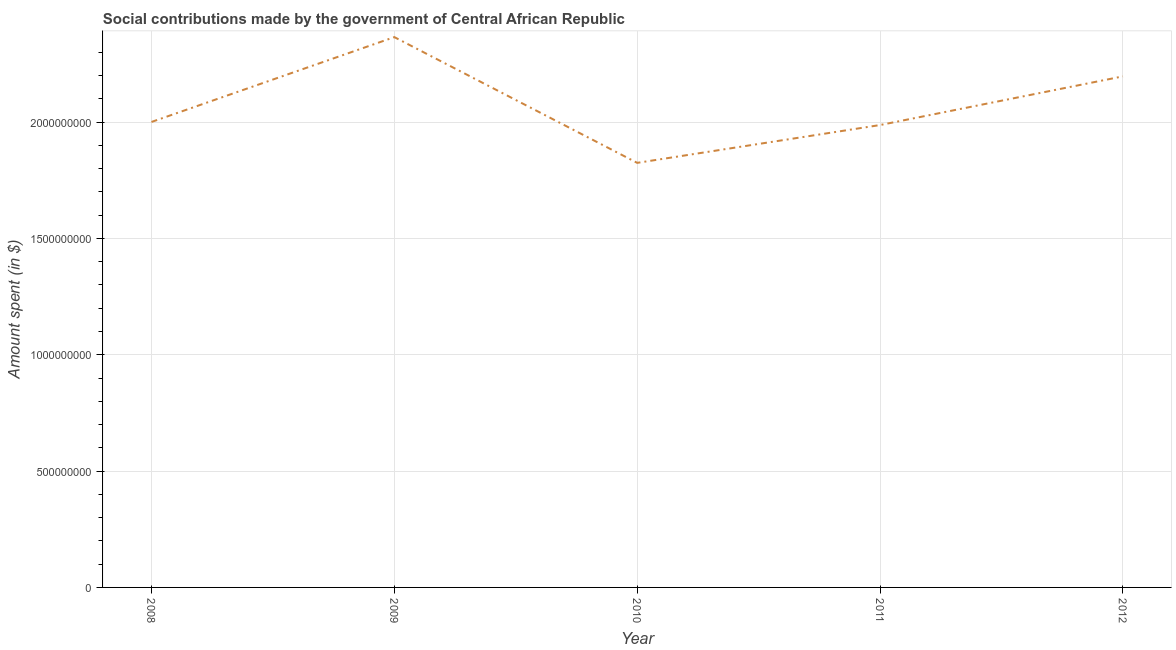What is the amount spent in making social contributions in 2010?
Make the answer very short. 1.82e+09. Across all years, what is the maximum amount spent in making social contributions?
Offer a terse response. 2.37e+09. Across all years, what is the minimum amount spent in making social contributions?
Provide a succinct answer. 1.82e+09. In which year was the amount spent in making social contributions maximum?
Give a very brief answer. 2009. In which year was the amount spent in making social contributions minimum?
Make the answer very short. 2010. What is the sum of the amount spent in making social contributions?
Offer a very short reply. 1.04e+1. What is the difference between the amount spent in making social contributions in 2010 and 2011?
Offer a very short reply. -1.63e+08. What is the average amount spent in making social contributions per year?
Give a very brief answer. 2.08e+09. What is the median amount spent in making social contributions?
Provide a short and direct response. 2.00e+09. What is the ratio of the amount spent in making social contributions in 2009 to that in 2011?
Provide a succinct answer. 1.19. What is the difference between the highest and the second highest amount spent in making social contributions?
Ensure brevity in your answer.  1.69e+08. What is the difference between the highest and the lowest amount spent in making social contributions?
Make the answer very short. 5.41e+08. In how many years, is the amount spent in making social contributions greater than the average amount spent in making social contributions taken over all years?
Offer a terse response. 2. Does the amount spent in making social contributions monotonically increase over the years?
Your answer should be very brief. No. How many lines are there?
Make the answer very short. 1. What is the difference between two consecutive major ticks on the Y-axis?
Offer a very short reply. 5.00e+08. Are the values on the major ticks of Y-axis written in scientific E-notation?
Offer a terse response. No. Does the graph contain any zero values?
Make the answer very short. No. What is the title of the graph?
Your answer should be very brief. Social contributions made by the government of Central African Republic. What is the label or title of the Y-axis?
Your response must be concise. Amount spent (in $). What is the Amount spent (in $) of 2008?
Your response must be concise. 2.00e+09. What is the Amount spent (in $) in 2009?
Keep it short and to the point. 2.37e+09. What is the Amount spent (in $) in 2010?
Keep it short and to the point. 1.82e+09. What is the Amount spent (in $) of 2011?
Your response must be concise. 1.99e+09. What is the Amount spent (in $) in 2012?
Provide a succinct answer. 2.20e+09. What is the difference between the Amount spent (in $) in 2008 and 2009?
Offer a terse response. -3.65e+08. What is the difference between the Amount spent (in $) in 2008 and 2010?
Give a very brief answer. 1.76e+08. What is the difference between the Amount spent (in $) in 2008 and 2011?
Ensure brevity in your answer.  1.32e+07. What is the difference between the Amount spent (in $) in 2008 and 2012?
Make the answer very short. -1.96e+08. What is the difference between the Amount spent (in $) in 2009 and 2010?
Provide a succinct answer. 5.41e+08. What is the difference between the Amount spent (in $) in 2009 and 2011?
Make the answer very short. 3.78e+08. What is the difference between the Amount spent (in $) in 2009 and 2012?
Offer a terse response. 1.69e+08. What is the difference between the Amount spent (in $) in 2010 and 2011?
Ensure brevity in your answer.  -1.63e+08. What is the difference between the Amount spent (in $) in 2010 and 2012?
Give a very brief answer. -3.72e+08. What is the difference between the Amount spent (in $) in 2011 and 2012?
Offer a terse response. -2.09e+08. What is the ratio of the Amount spent (in $) in 2008 to that in 2009?
Make the answer very short. 0.85. What is the ratio of the Amount spent (in $) in 2008 to that in 2010?
Provide a succinct answer. 1.1. What is the ratio of the Amount spent (in $) in 2008 to that in 2012?
Make the answer very short. 0.91. What is the ratio of the Amount spent (in $) in 2009 to that in 2010?
Provide a short and direct response. 1.3. What is the ratio of the Amount spent (in $) in 2009 to that in 2011?
Your response must be concise. 1.19. What is the ratio of the Amount spent (in $) in 2009 to that in 2012?
Provide a succinct answer. 1.08. What is the ratio of the Amount spent (in $) in 2010 to that in 2011?
Keep it short and to the point. 0.92. What is the ratio of the Amount spent (in $) in 2010 to that in 2012?
Make the answer very short. 0.83. What is the ratio of the Amount spent (in $) in 2011 to that in 2012?
Ensure brevity in your answer.  0.91. 